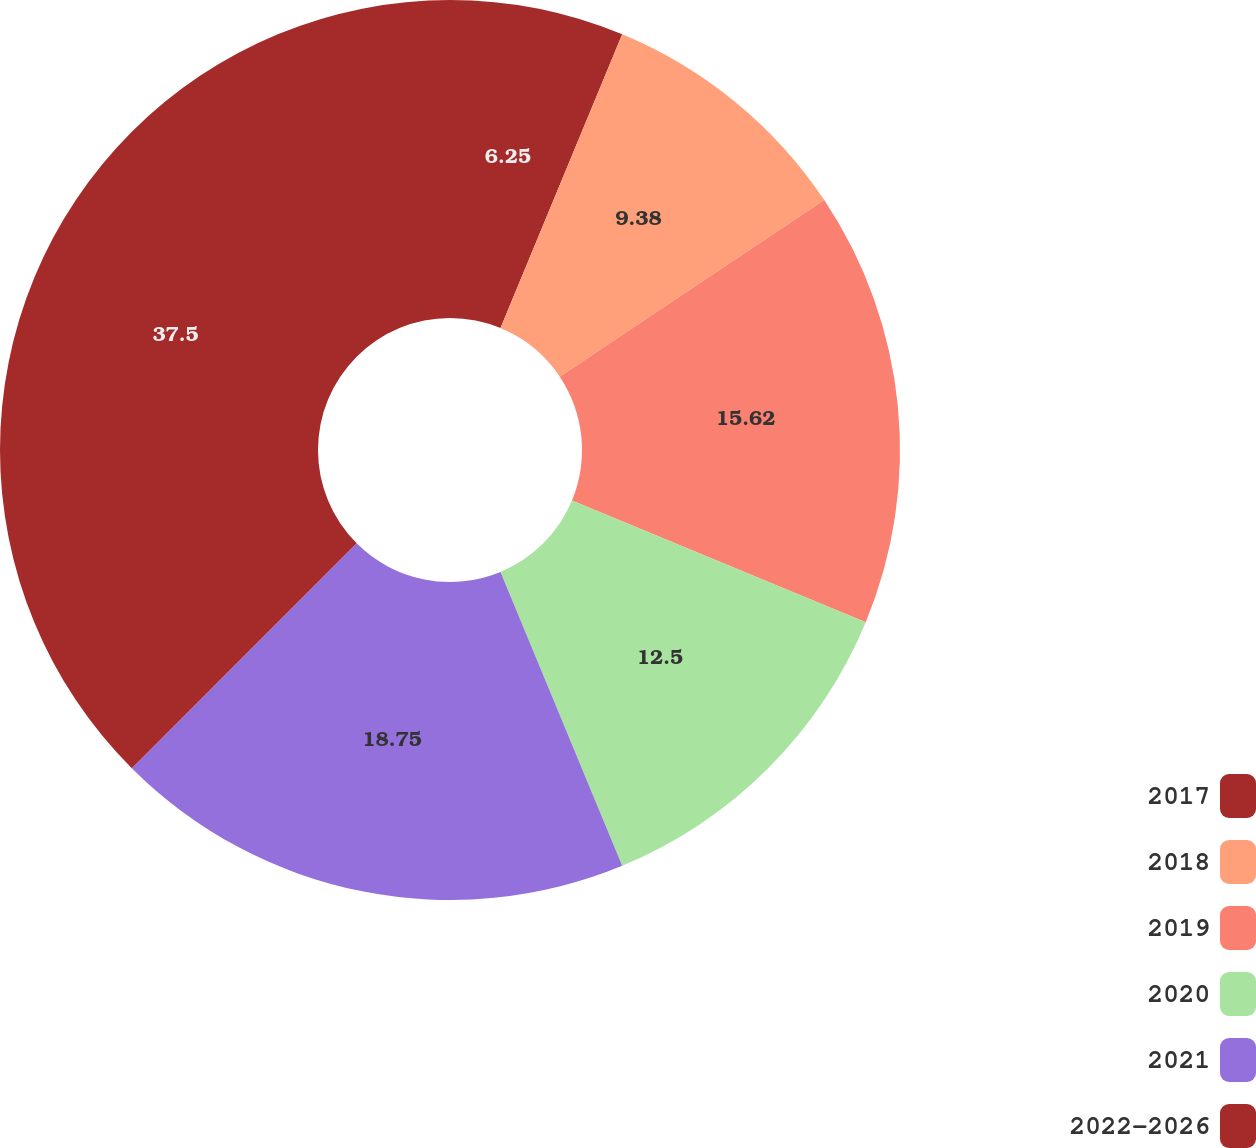Convert chart to OTSL. <chart><loc_0><loc_0><loc_500><loc_500><pie_chart><fcel>2017<fcel>2018<fcel>2019<fcel>2020<fcel>2021<fcel>2022-2026<nl><fcel>6.25%<fcel>9.38%<fcel>15.62%<fcel>12.5%<fcel>18.75%<fcel>37.5%<nl></chart> 